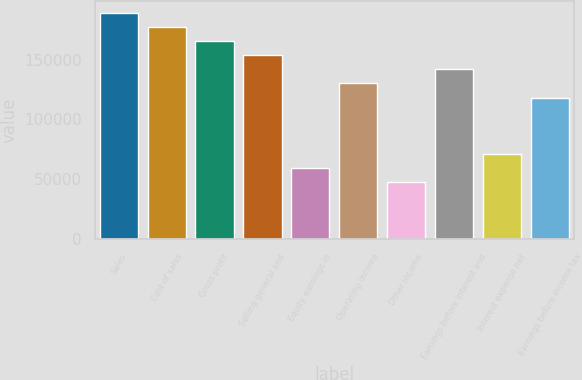Convert chart. <chart><loc_0><loc_0><loc_500><loc_500><bar_chart><fcel>Sales<fcel>Cost of sales<fcel>Gross profit<fcel>Selling general and<fcel>Equity earnings in<fcel>Operating income<fcel>Other income<fcel>Earnings before interest and<fcel>Interest expense net<fcel>Earnings before income tax<nl><fcel>189140<fcel>177319<fcel>165498<fcel>153677<fcel>59108.9<fcel>130035<fcel>47287.9<fcel>141856<fcel>70929.9<fcel>118214<nl></chart> 